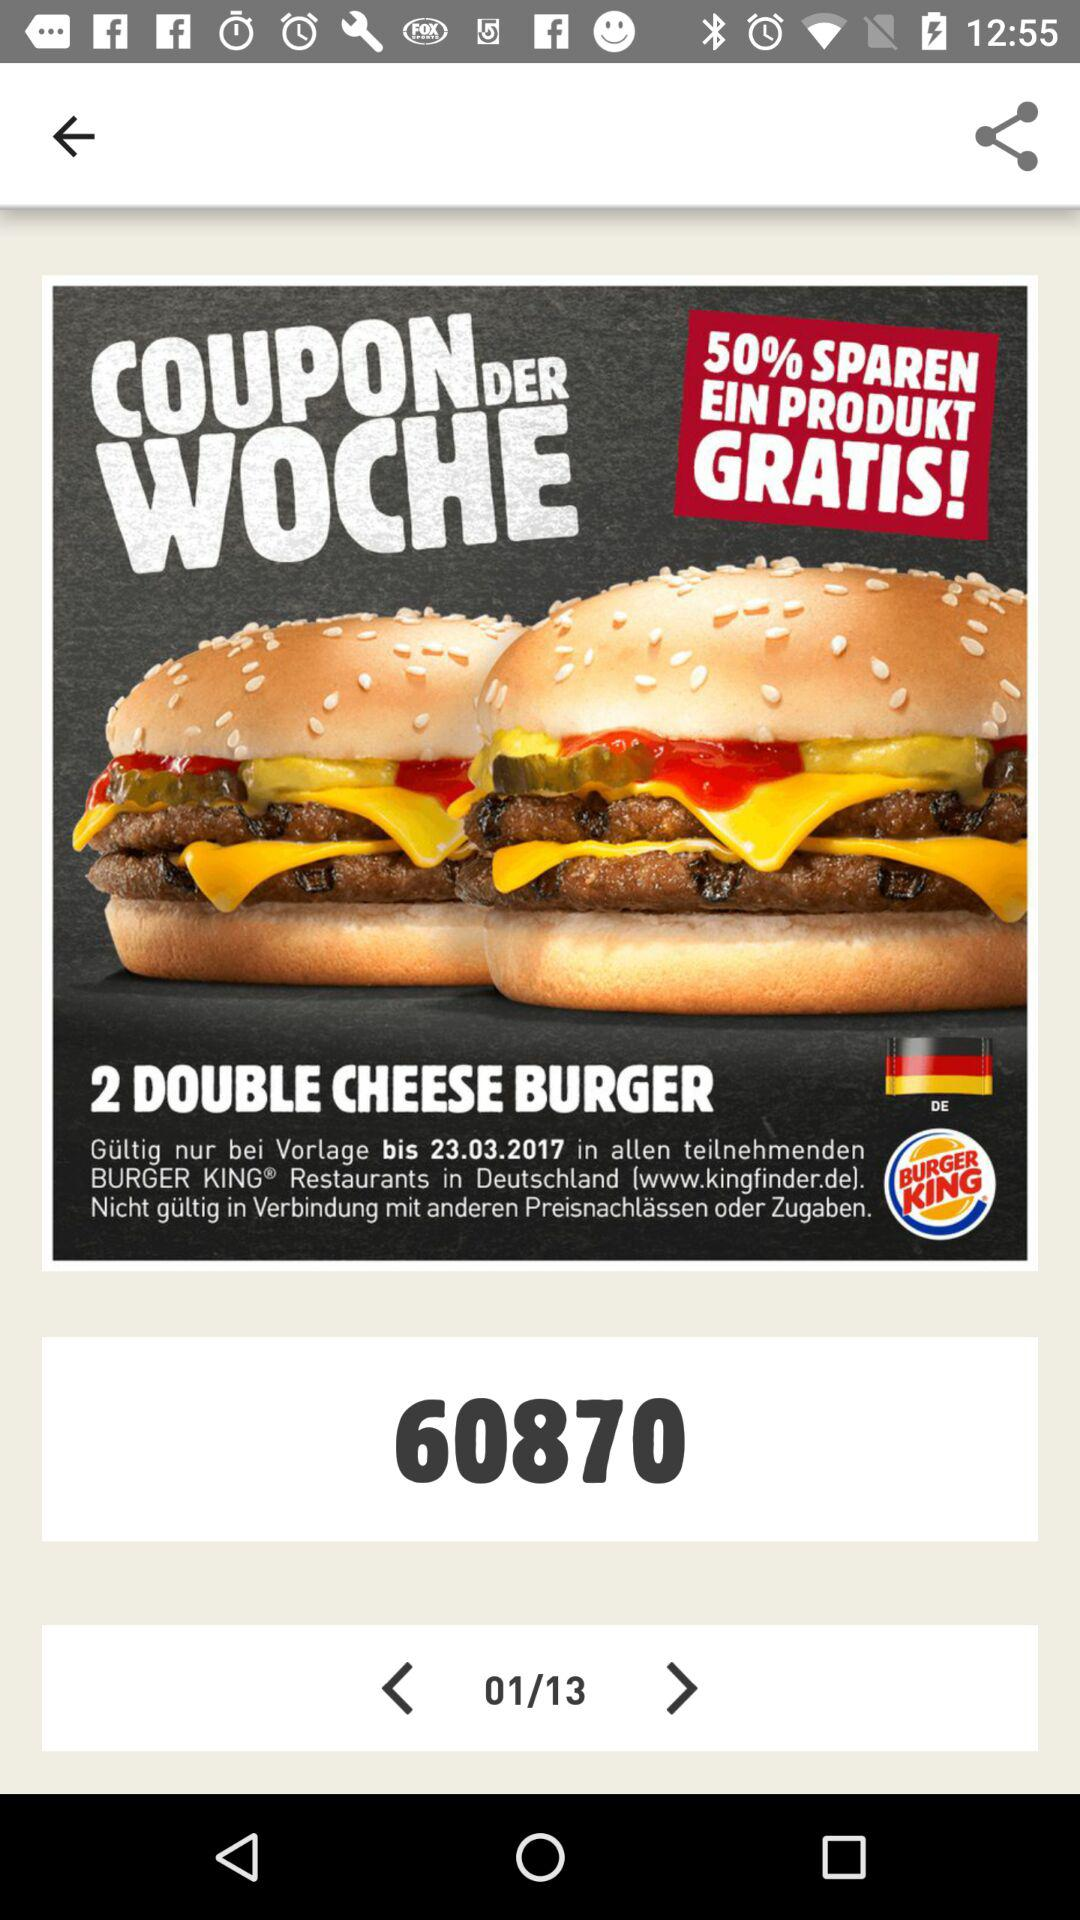How many pages in total are there? There are 13 pages in total. 